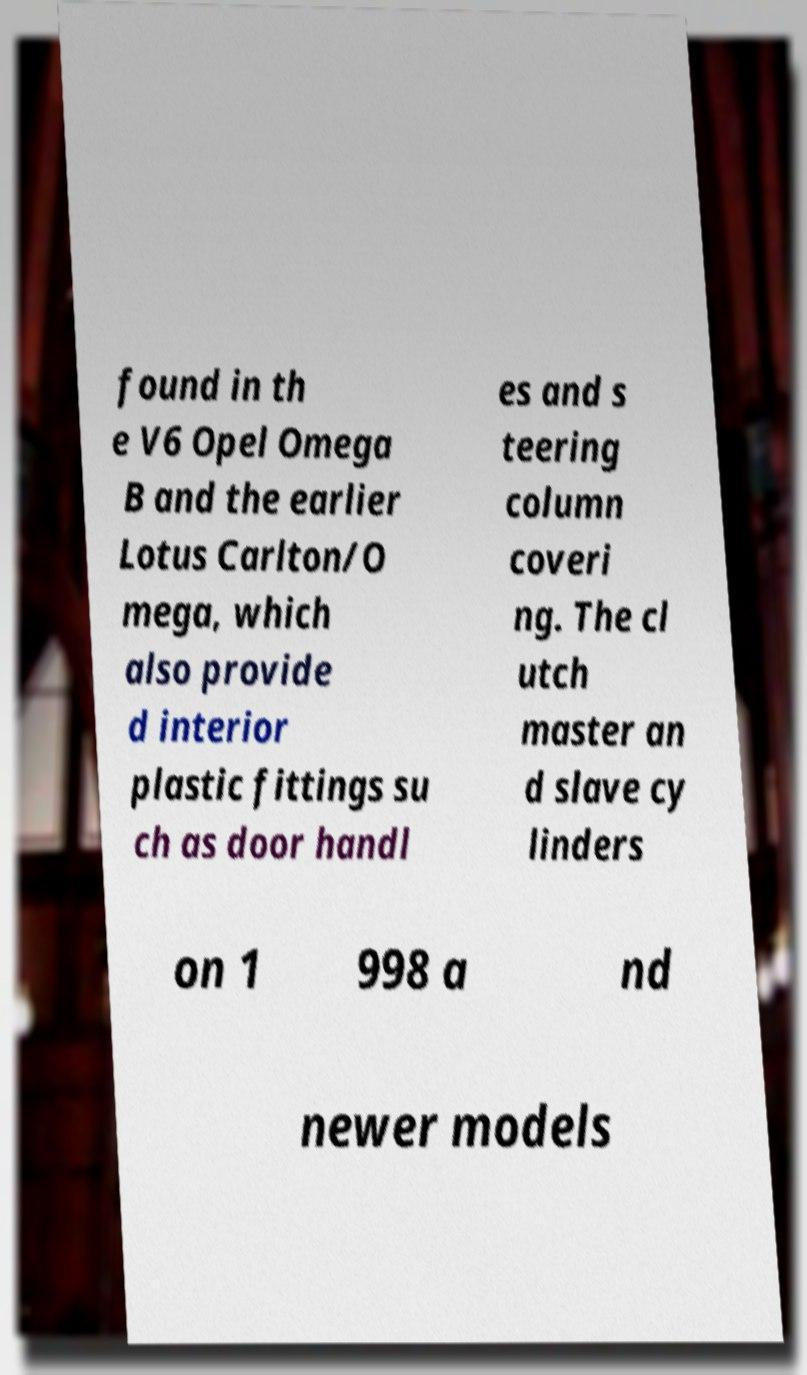There's text embedded in this image that I need extracted. Can you transcribe it verbatim? found in th e V6 Opel Omega B and the earlier Lotus Carlton/O mega, which also provide d interior plastic fittings su ch as door handl es and s teering column coveri ng. The cl utch master an d slave cy linders on 1 998 a nd newer models 